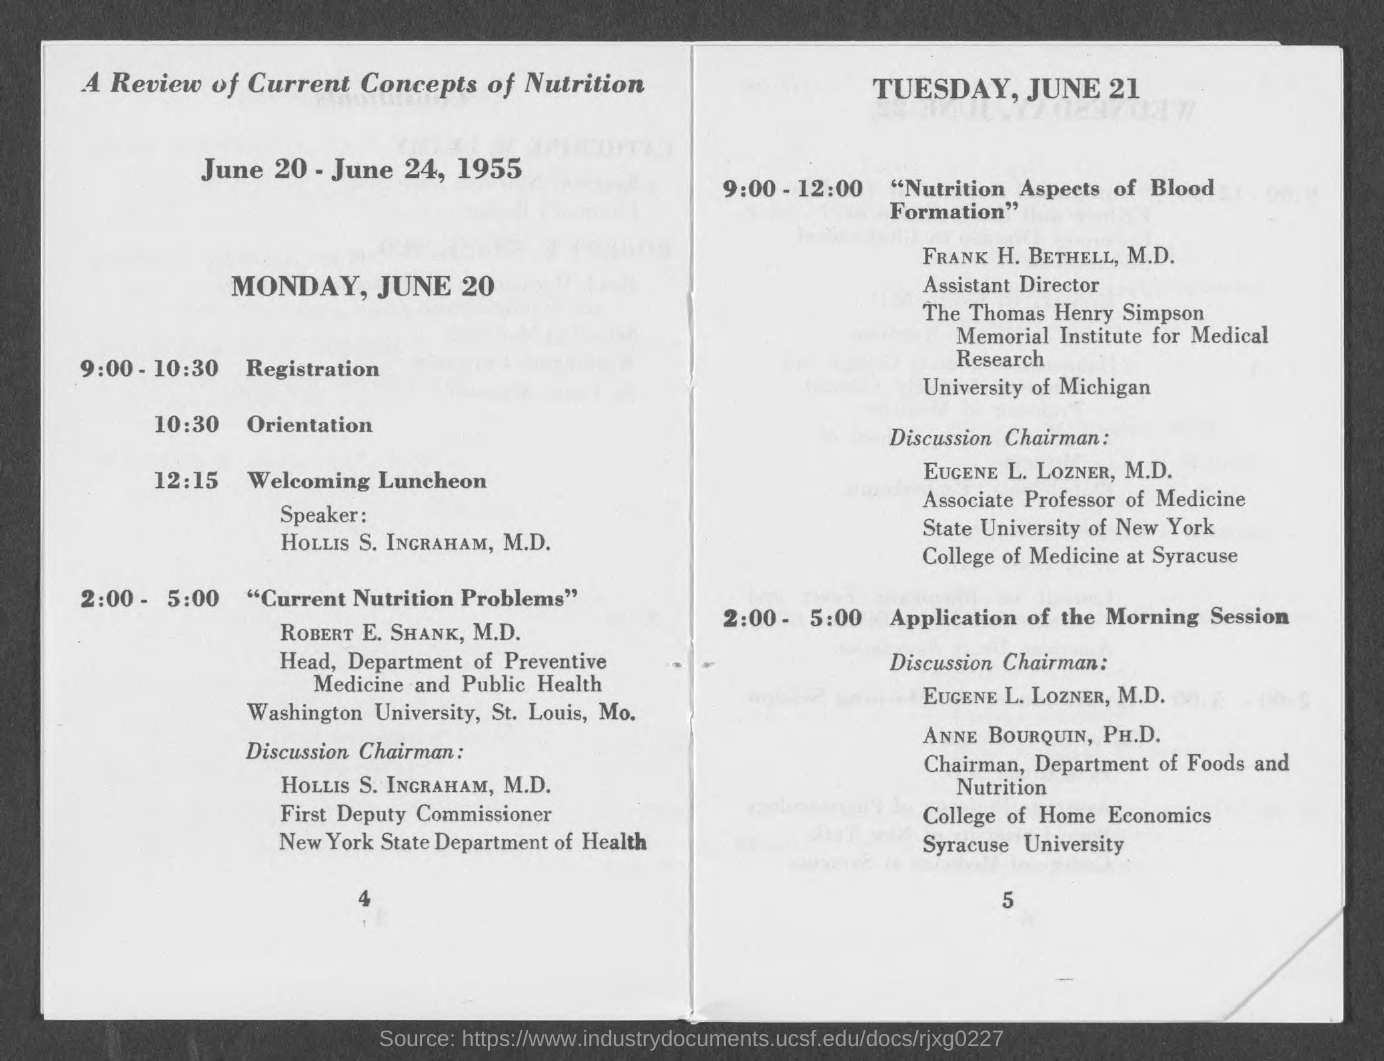List a handful of essential elements in this visual. Robert E. Shank, M.D. is the head of the department of Preventive Medicine and Public Health. The registration for the sessions will take place from 9:00-10:30. On Monday, June 20, from 2:00 PM to 5:00 PM, the topic of current nutrition problems will be discussed. The discussion chairman for the session on "Nutrition Aspects of Blood Formation" is Eugene L. Lozner. The orientation for the sessions held on Monday, June 20, will take place at 10:30. 